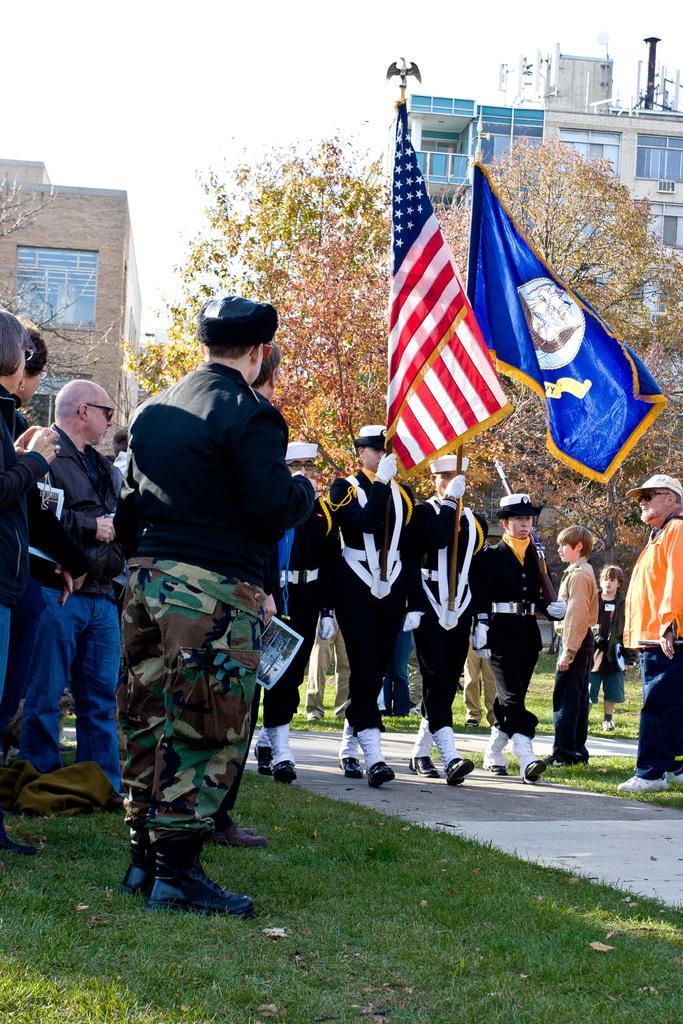Describe this image in one or two sentences. In this picture there are people in the center of the image, by holding flags in there hands, there is grass land at the bottom side of the image and there are trees and buildings in the background area of the image. 